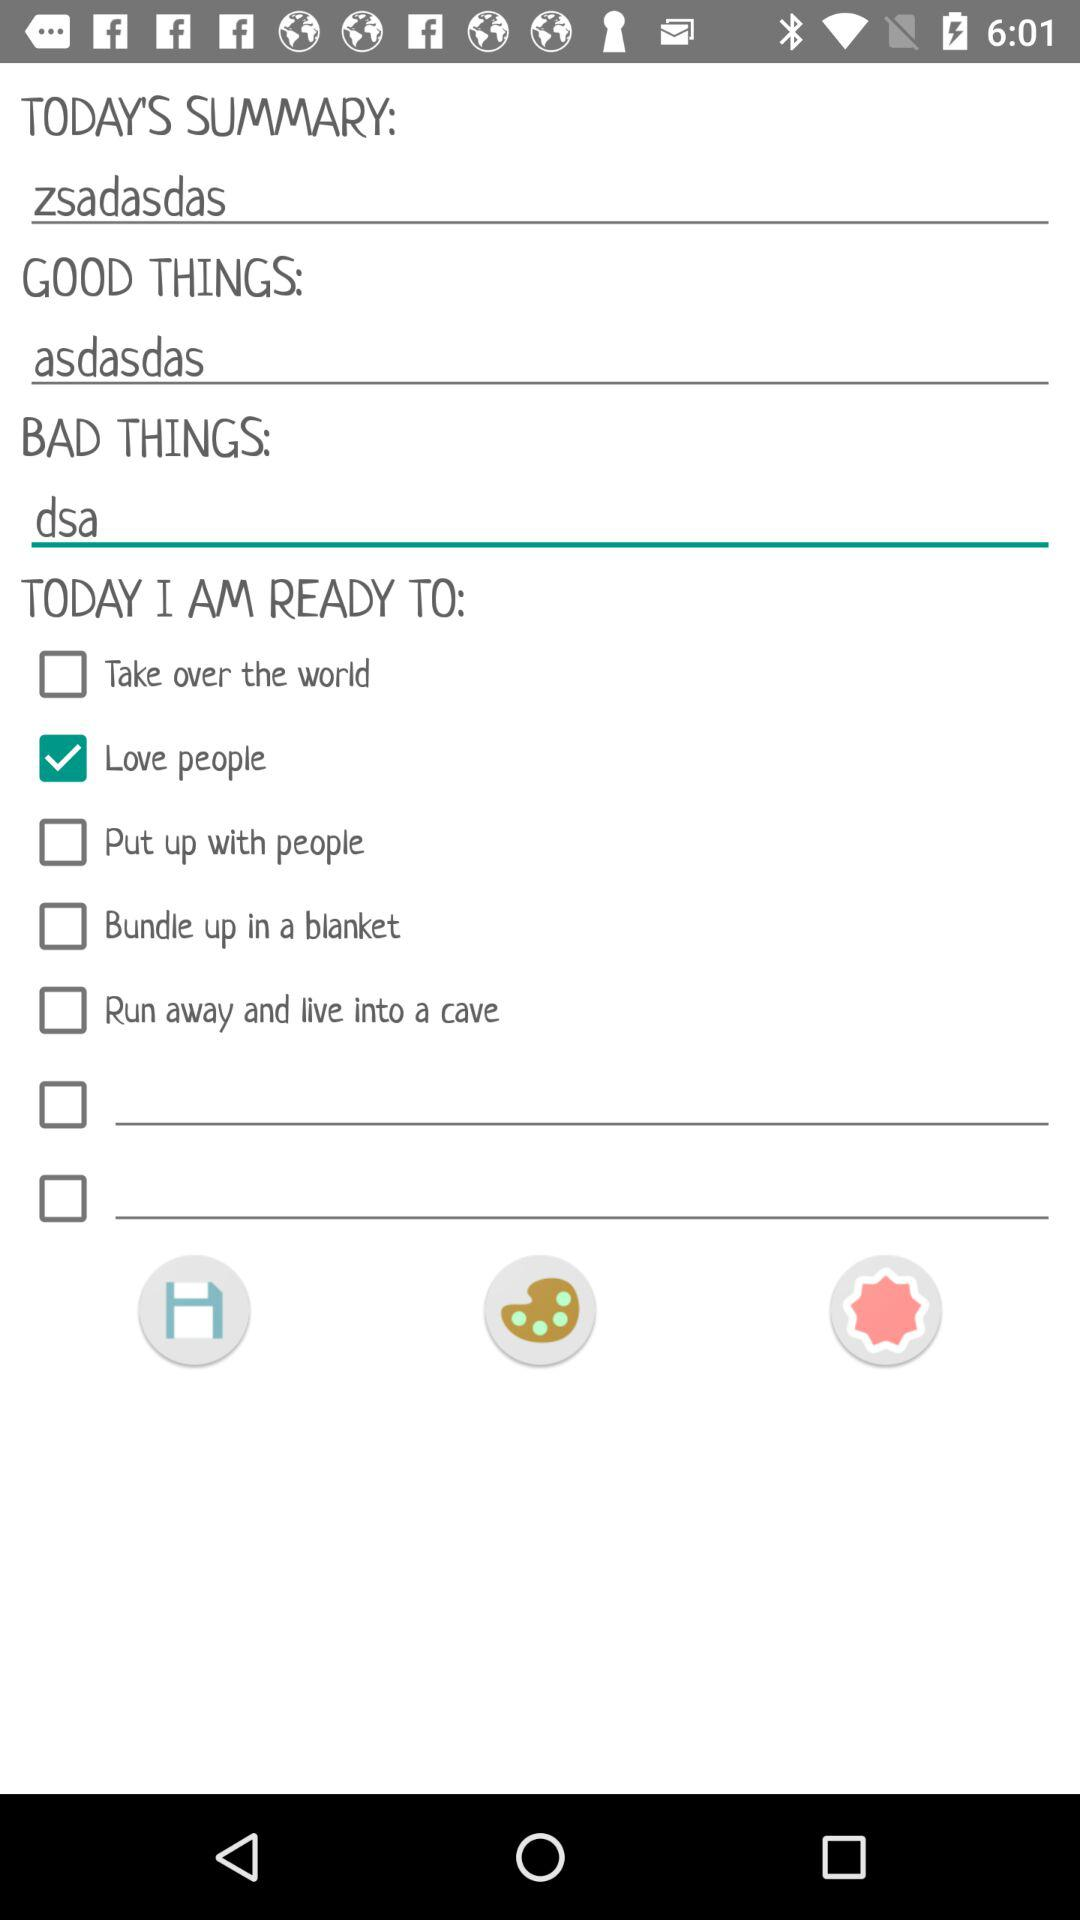What is entered in the "BAD THINGS"? In the "BAD THINGS", "dsa" is entered. 